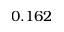Convert formula to latex. <formula><loc_0><loc_0><loc_500><loc_500>0 . 1 6 2</formula> 